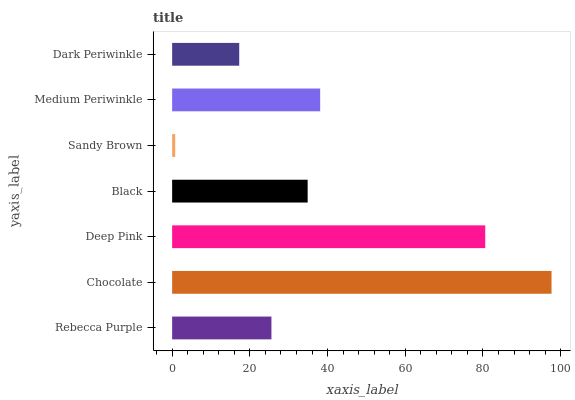Is Sandy Brown the minimum?
Answer yes or no. Yes. Is Chocolate the maximum?
Answer yes or no. Yes. Is Deep Pink the minimum?
Answer yes or no. No. Is Deep Pink the maximum?
Answer yes or no. No. Is Chocolate greater than Deep Pink?
Answer yes or no. Yes. Is Deep Pink less than Chocolate?
Answer yes or no. Yes. Is Deep Pink greater than Chocolate?
Answer yes or no. No. Is Chocolate less than Deep Pink?
Answer yes or no. No. Is Black the high median?
Answer yes or no. Yes. Is Black the low median?
Answer yes or no. Yes. Is Sandy Brown the high median?
Answer yes or no. No. Is Deep Pink the low median?
Answer yes or no. No. 